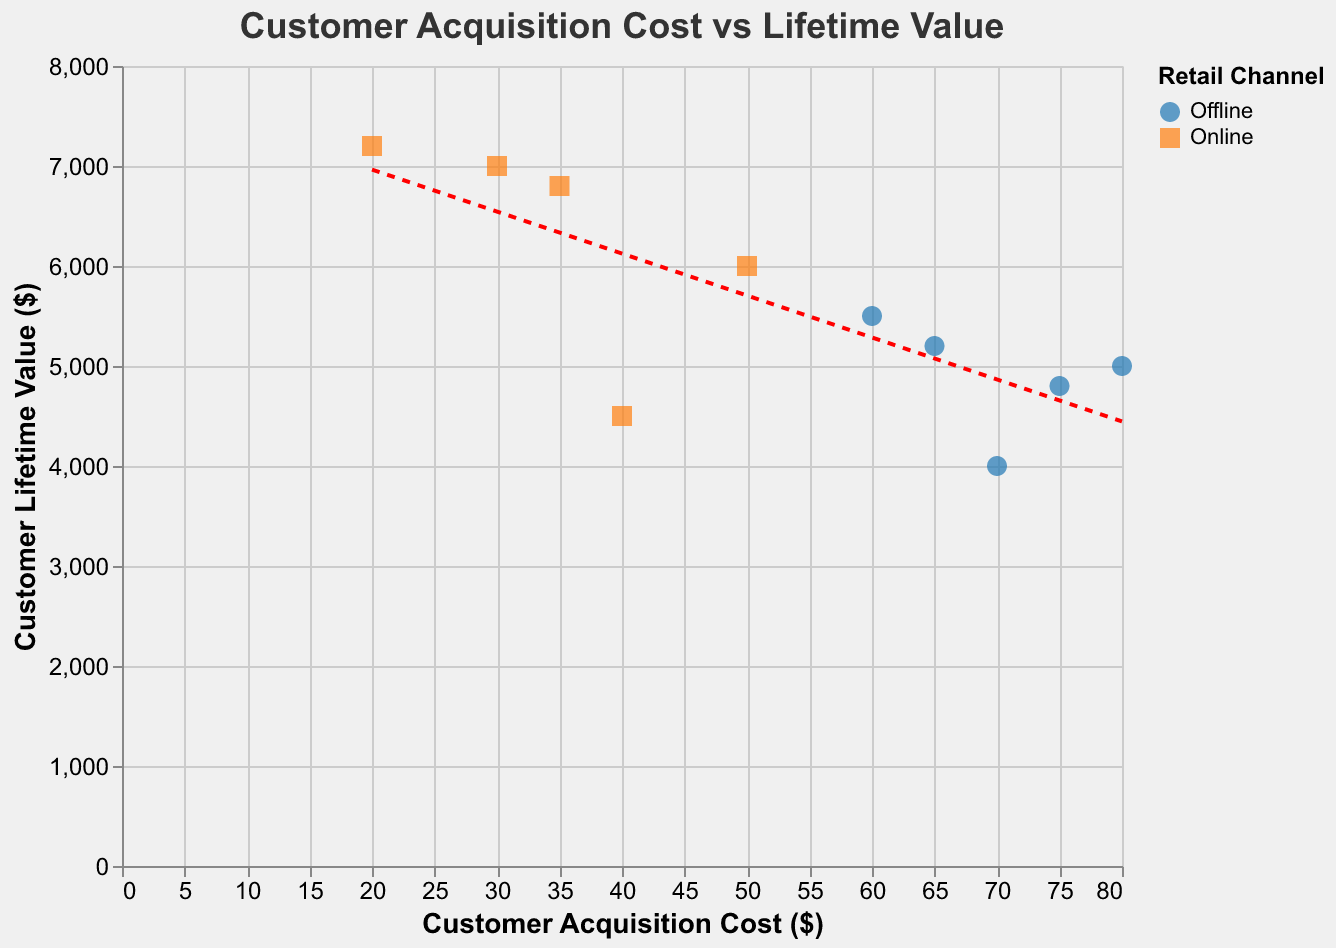what's the title of the figure? The title is displayed at the top of the figure in bold text. It provides a summary of the plot's content.
Answer: Customer Acquisition Cost vs Lifetime Value how many data points are displayed in the figure? By counting each point on the scatter plot, we observe the number of data points representing various customers. There are 10 data points.
Answer: 10 which retail channel has the highest Customer Lifetime Value? By observing the y-axis and identifying the highest point on the scatter plot, we see the label associated with that point. The highest Customer Lifetime Value is associated with the Online channel.
Answer: Online what is the Acquisition Cost and Customer Lifetime Value for Shopify? Hovering over the plot would reveal the tooltip with Shopify's values, but without interaction, we locate Shopify in the data list: Acquisition Cost is 20, and Customer Lifetime Value is 7200.
Answer: 20, 7200 does the trend line indicate a positive or negative correlation between Acquisition Cost and Customer Lifetime Value? The direction of the trend line indicates the correlation. It slopes upwards, reflecting a positive correlation between Acquisition Cost and Customer Lifetime Value.
Answer: Positive which customer has the highest Acquisition Cost in the Offline channel? Observing the scatter plot and distinguishing points by color and shape for the Offline channel, we identify the highest x-axis value. The customer is Walmart with an Acquisition Cost of 80.
Answer: Walmart what's the total Customer Lifetime Value for all customers in the Online channel? Adding all the Customer Lifetime Values for the Online customers: 6000 (Amazon) + 4500 (eBay) + 7000 (Alibaba) + 7200 (Shopify) + 6800 (Rakuten) equals 31500.
Answer: 31500 compare the Customer Lifetime Value of Amazon and Macy’s. Which has a higher value and by how much? Looking at the y-values for Amazon (6000) and Macy’s (4000) and calculating the difference: 6000 - 4000 equals 2000. Amazon has a higher value by 2000.
Answer: Amazon by 2000 